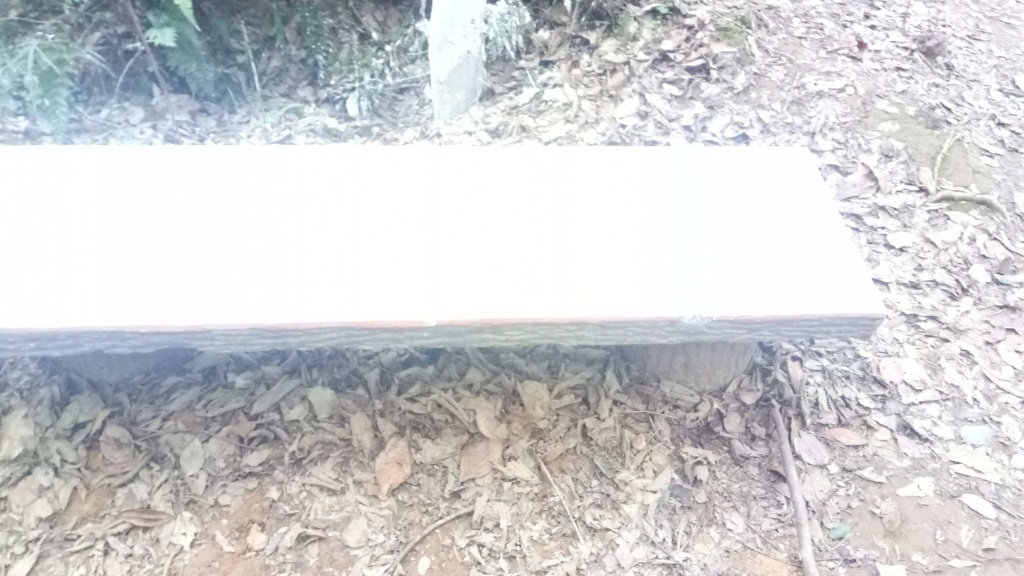Is the lighting strong in the image? The lighting in the photo appears to be moderately strong, casting defined shadows beneath the bench, indicating that the photo may have been taken on a bright day, even though the direct sunlight does not seem to be overly harsh. 